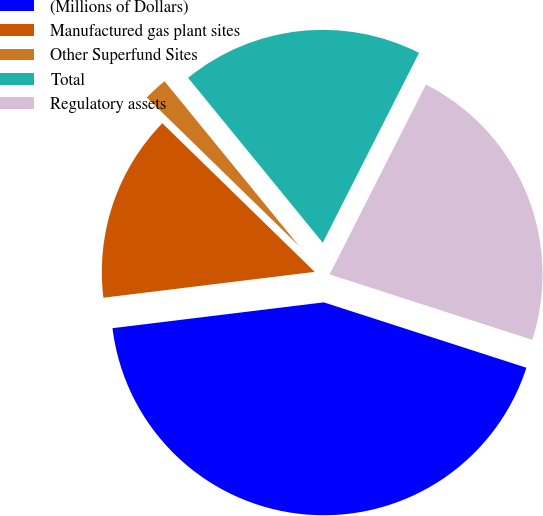Convert chart to OTSL. <chart><loc_0><loc_0><loc_500><loc_500><pie_chart><fcel>(Millions of Dollars)<fcel>Manufactured gas plant sites<fcel>Other Superfund Sites<fcel>Total<fcel>Regulatory assets<nl><fcel>43.1%<fcel>14.24%<fcel>1.8%<fcel>18.37%<fcel>22.5%<nl></chart> 